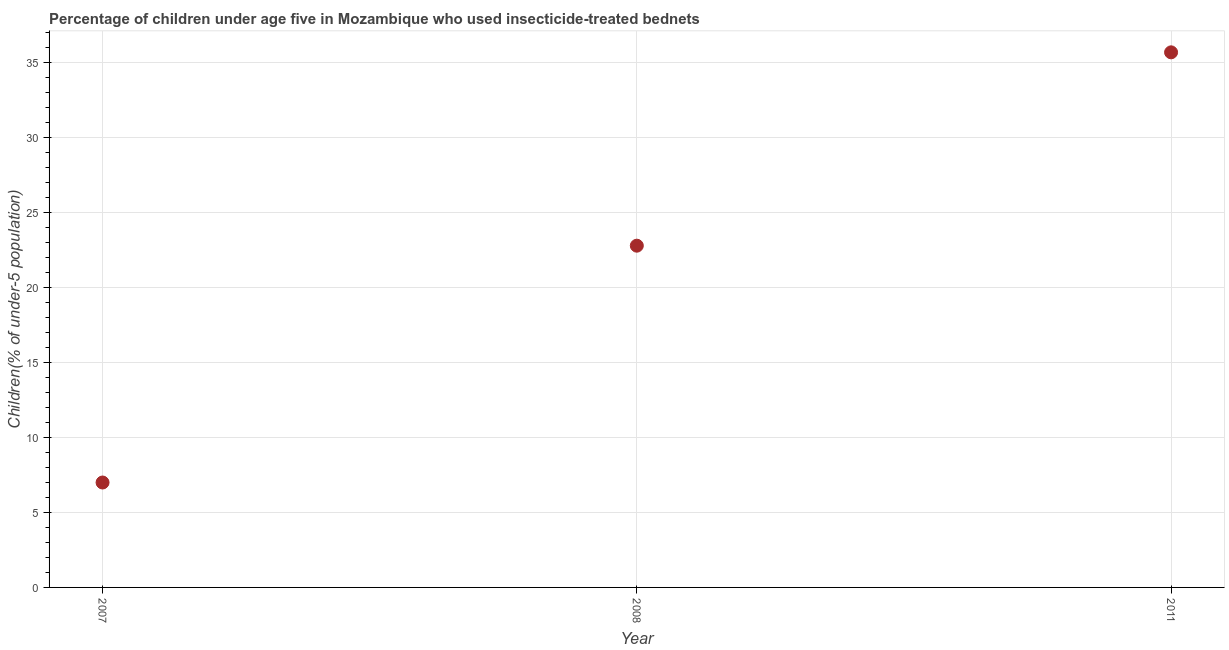What is the percentage of children who use of insecticide-treated bed nets in 2011?
Your answer should be very brief. 35.7. Across all years, what is the maximum percentage of children who use of insecticide-treated bed nets?
Give a very brief answer. 35.7. In which year was the percentage of children who use of insecticide-treated bed nets maximum?
Offer a terse response. 2011. What is the sum of the percentage of children who use of insecticide-treated bed nets?
Your answer should be compact. 65.5. What is the difference between the percentage of children who use of insecticide-treated bed nets in 2007 and 2011?
Your answer should be very brief. -28.7. What is the average percentage of children who use of insecticide-treated bed nets per year?
Ensure brevity in your answer.  21.83. What is the median percentage of children who use of insecticide-treated bed nets?
Offer a terse response. 22.8. In how many years, is the percentage of children who use of insecticide-treated bed nets greater than 35 %?
Provide a short and direct response. 1. Do a majority of the years between 2007 and 2008 (inclusive) have percentage of children who use of insecticide-treated bed nets greater than 15 %?
Make the answer very short. No. What is the ratio of the percentage of children who use of insecticide-treated bed nets in 2008 to that in 2011?
Provide a succinct answer. 0.64. What is the difference between the highest and the second highest percentage of children who use of insecticide-treated bed nets?
Your response must be concise. 12.9. What is the difference between the highest and the lowest percentage of children who use of insecticide-treated bed nets?
Make the answer very short. 28.7. In how many years, is the percentage of children who use of insecticide-treated bed nets greater than the average percentage of children who use of insecticide-treated bed nets taken over all years?
Your response must be concise. 2. How many dotlines are there?
Provide a succinct answer. 1. How many years are there in the graph?
Make the answer very short. 3. What is the difference between two consecutive major ticks on the Y-axis?
Ensure brevity in your answer.  5. Are the values on the major ticks of Y-axis written in scientific E-notation?
Your response must be concise. No. Does the graph contain any zero values?
Your answer should be compact. No. What is the title of the graph?
Offer a very short reply. Percentage of children under age five in Mozambique who used insecticide-treated bednets. What is the label or title of the X-axis?
Your response must be concise. Year. What is the label or title of the Y-axis?
Offer a terse response. Children(% of under-5 population). What is the Children(% of under-5 population) in 2007?
Provide a succinct answer. 7. What is the Children(% of under-5 population) in 2008?
Your answer should be very brief. 22.8. What is the Children(% of under-5 population) in 2011?
Ensure brevity in your answer.  35.7. What is the difference between the Children(% of under-5 population) in 2007 and 2008?
Keep it short and to the point. -15.8. What is the difference between the Children(% of under-5 population) in 2007 and 2011?
Your response must be concise. -28.7. What is the ratio of the Children(% of under-5 population) in 2007 to that in 2008?
Offer a very short reply. 0.31. What is the ratio of the Children(% of under-5 population) in 2007 to that in 2011?
Provide a succinct answer. 0.2. What is the ratio of the Children(% of under-5 population) in 2008 to that in 2011?
Offer a terse response. 0.64. 